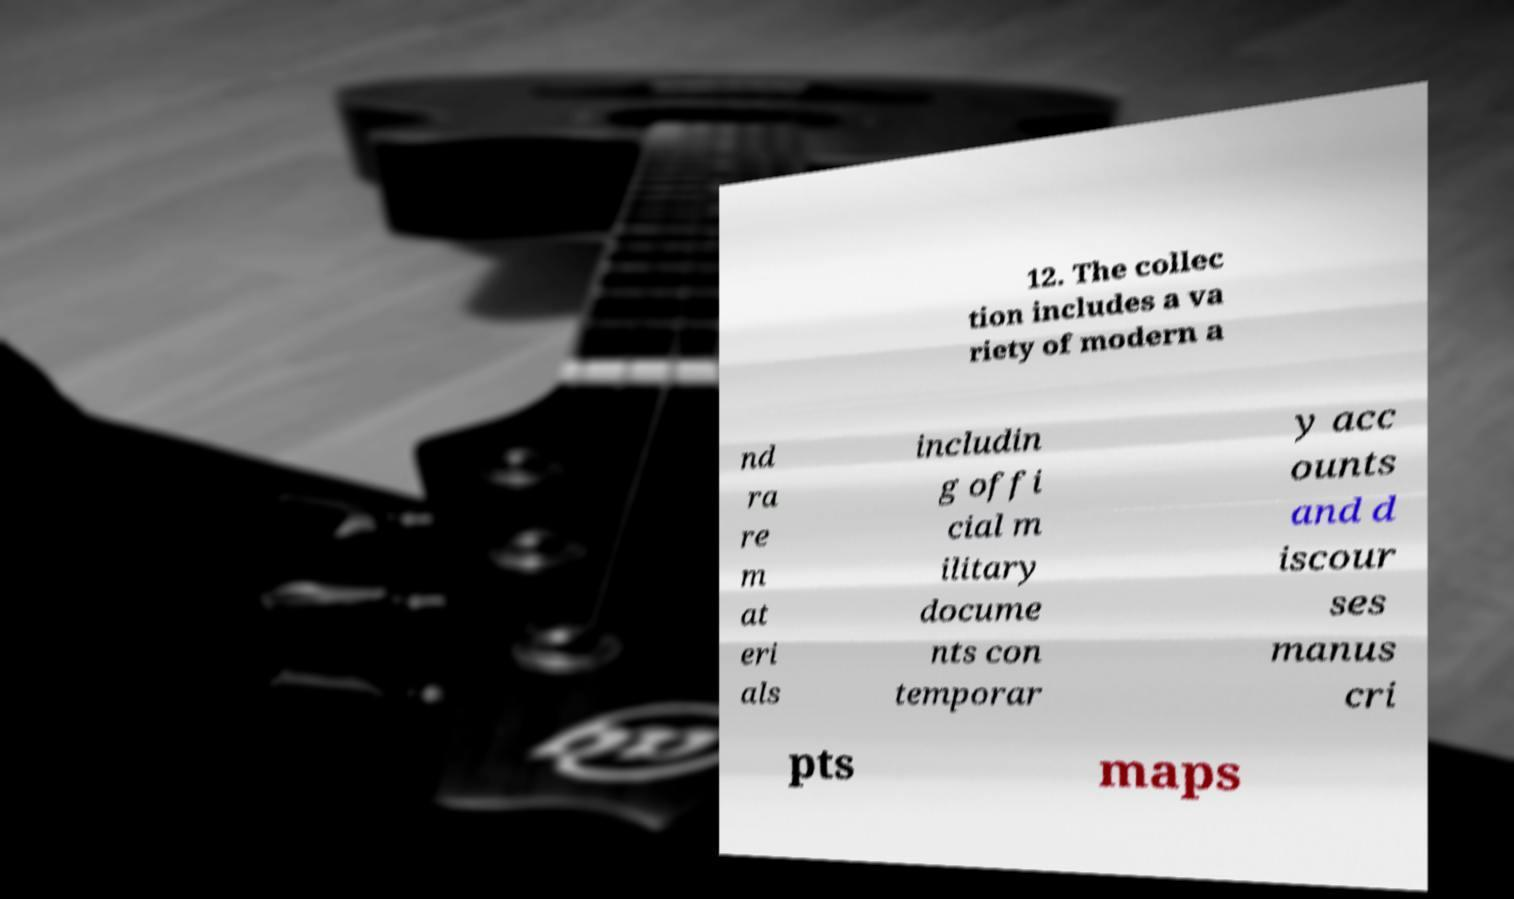I need the written content from this picture converted into text. Can you do that? 12. The collec tion includes a va riety of modern a nd ra re m at eri als includin g offi cial m ilitary docume nts con temporar y acc ounts and d iscour ses manus cri pts maps 